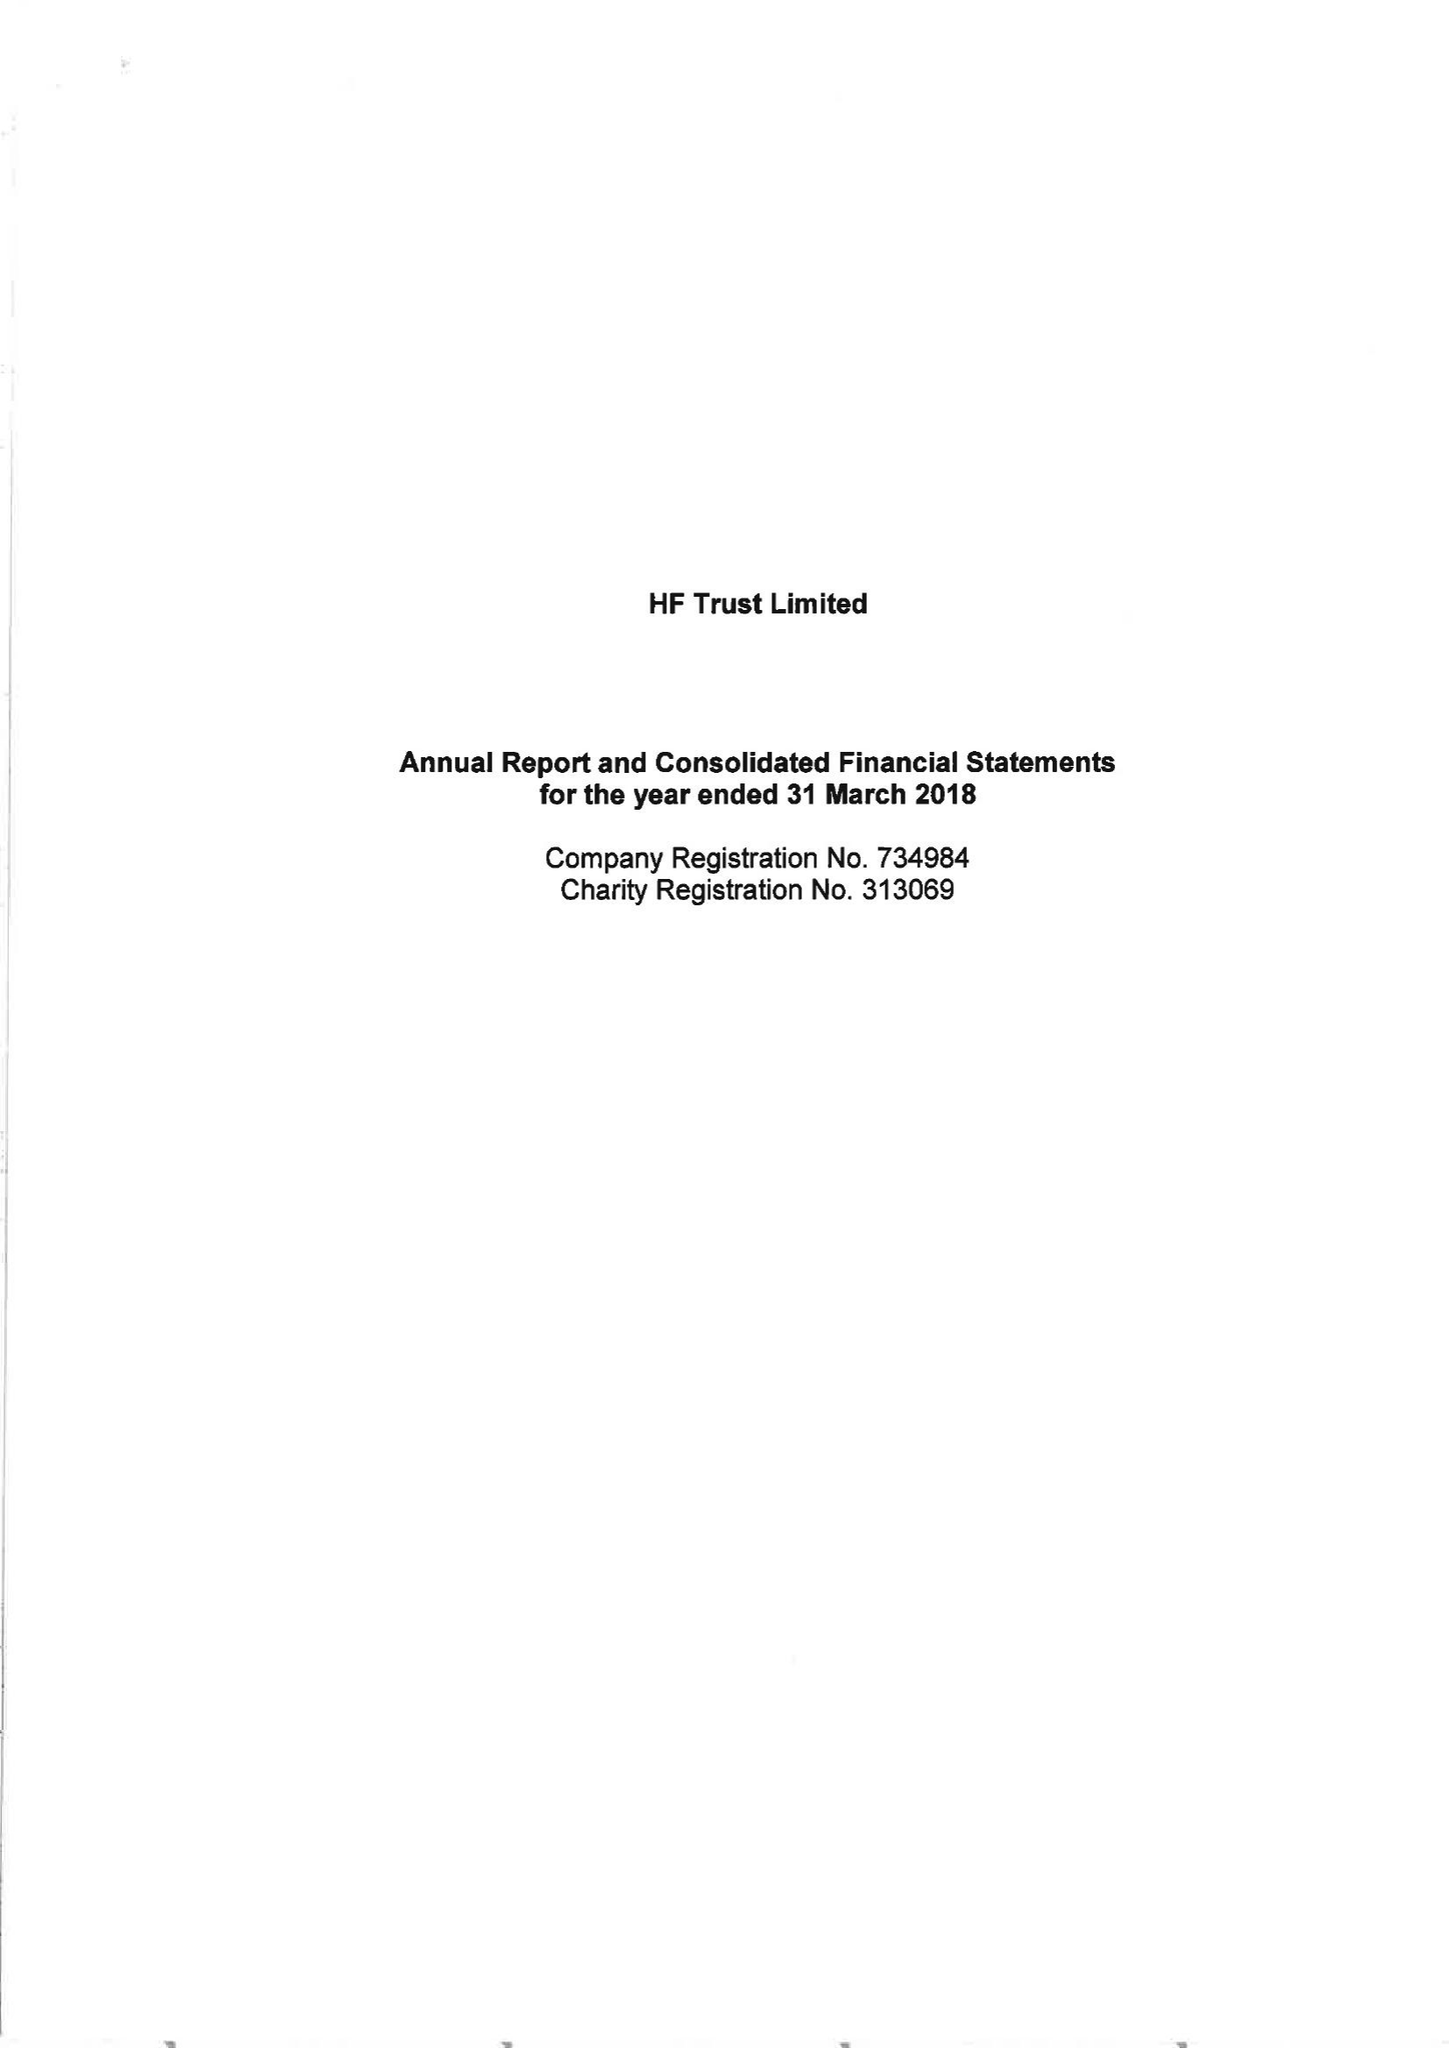What is the value for the address__post_town?
Answer the question using a single word or phrase. BRISTOL 